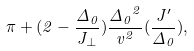<formula> <loc_0><loc_0><loc_500><loc_500>\pi + ( 2 - \frac { \Delta _ { 0 } } { J _ { \bot } } ) \frac { { \Delta _ { 0 } } ^ { 2 } } { v ^ { 2 } } { ( \frac { J ^ { \prime } } { \Delta _ { 0 } } ) } ,</formula> 